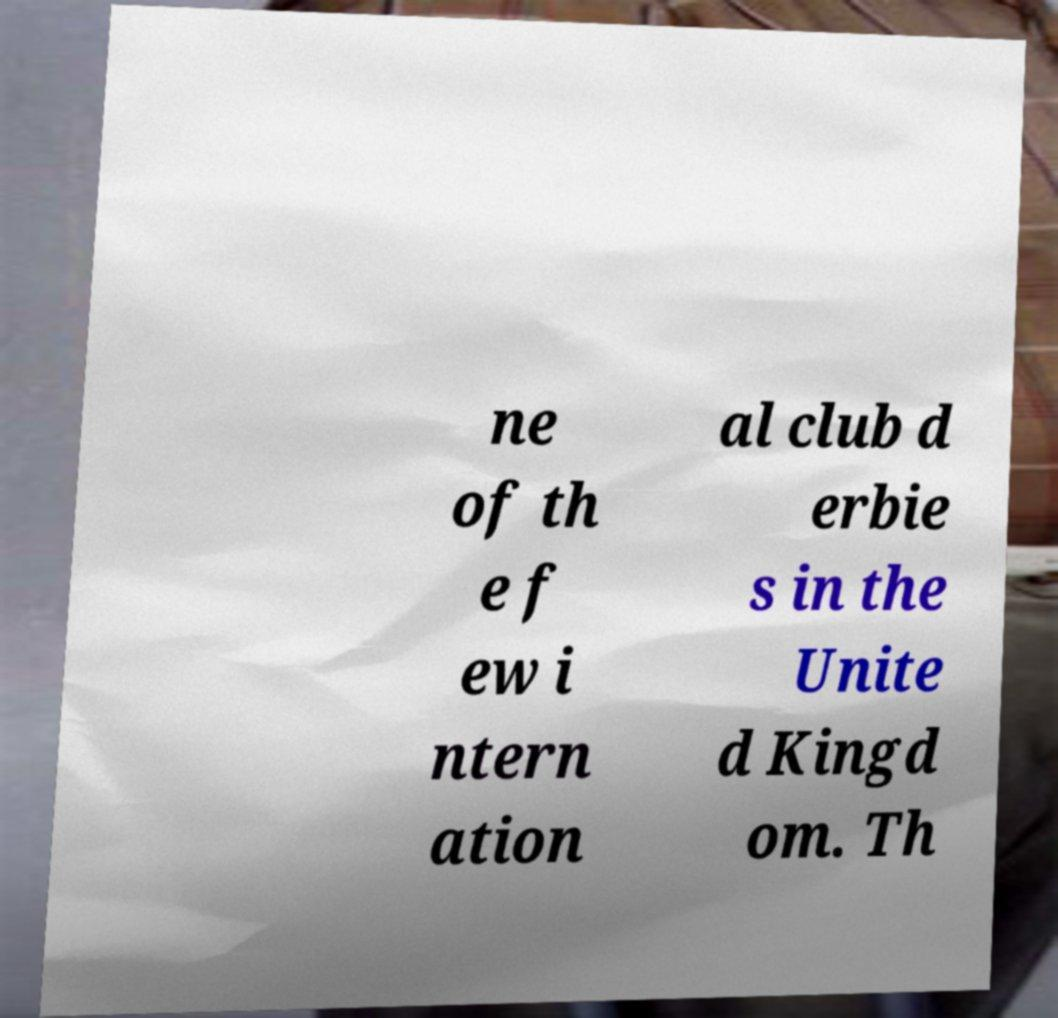I need the written content from this picture converted into text. Can you do that? ne of th e f ew i ntern ation al club d erbie s in the Unite d Kingd om. Th 